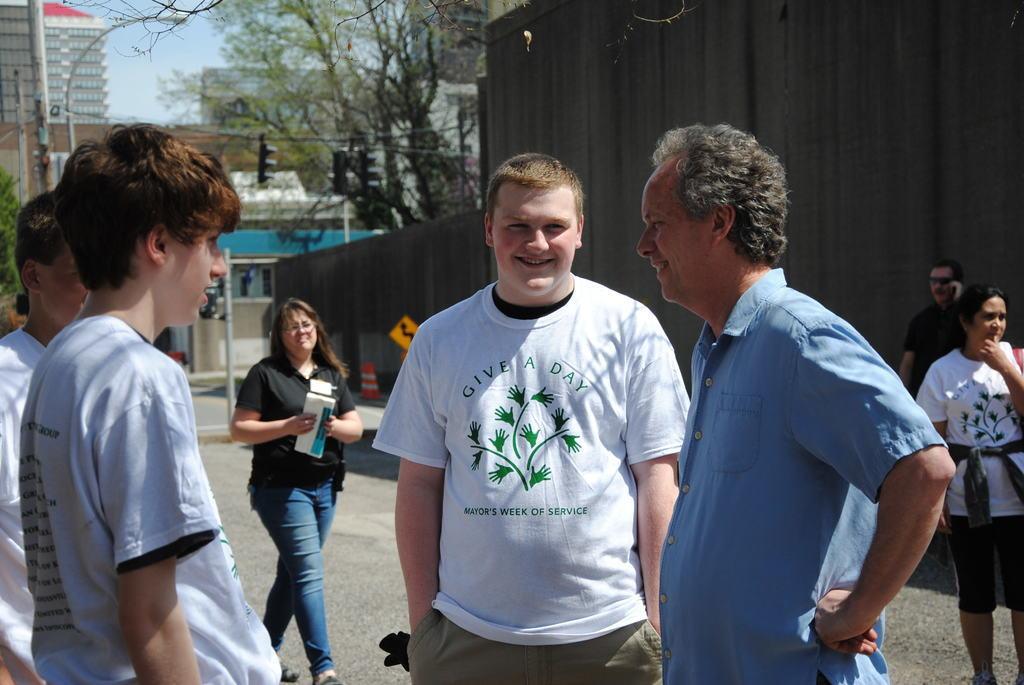Please provide a concise description of this image. In this image, we can see some people standing and at the right side there is a woman standing and there is a man talking on the mobile phone, there is a wall and there are some buildings and trees, we can see a sky. 